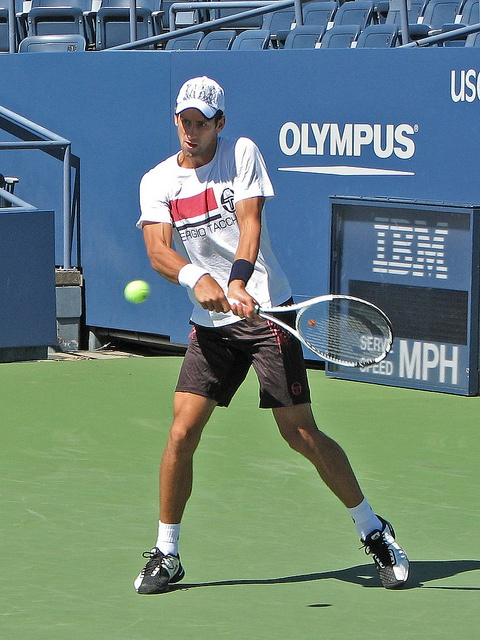Describe the objects in this image and their specific colors. I can see people in gray, black, and white tones, tennis racket in gray, white, and darkgray tones, chair in gray, blue, and black tones, chair in gray and darkgray tones, and chair in gray, blue, and navy tones in this image. 